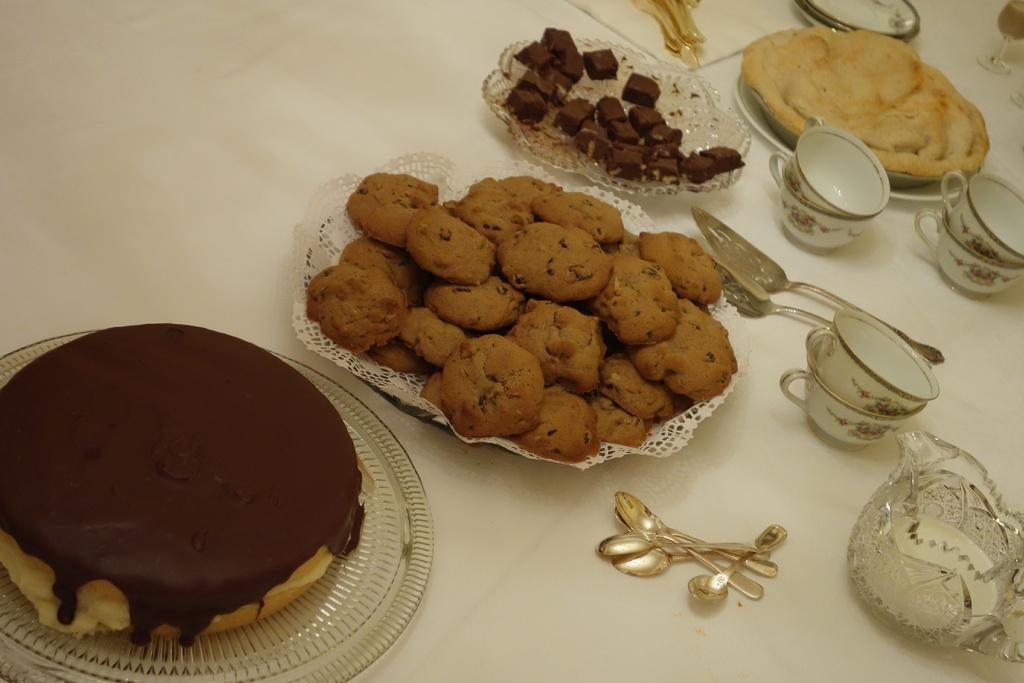What type of food items can be seen in the image? There are cookies, cake, and chocolates in the image. What is the food item on a platter in the image? The food item on a platter in the image is not specified, but it is mentioned that there are platters on the table. What utensils are visible in the image? Spoons and spatulas are visible in the image. What type of containers are present in the image? Cups, a jar, and glasses are present in the image. What is the chance of finding grain in the image? There is no mention of grain in the image, so it cannot be determined if there is a chance of finding it. 